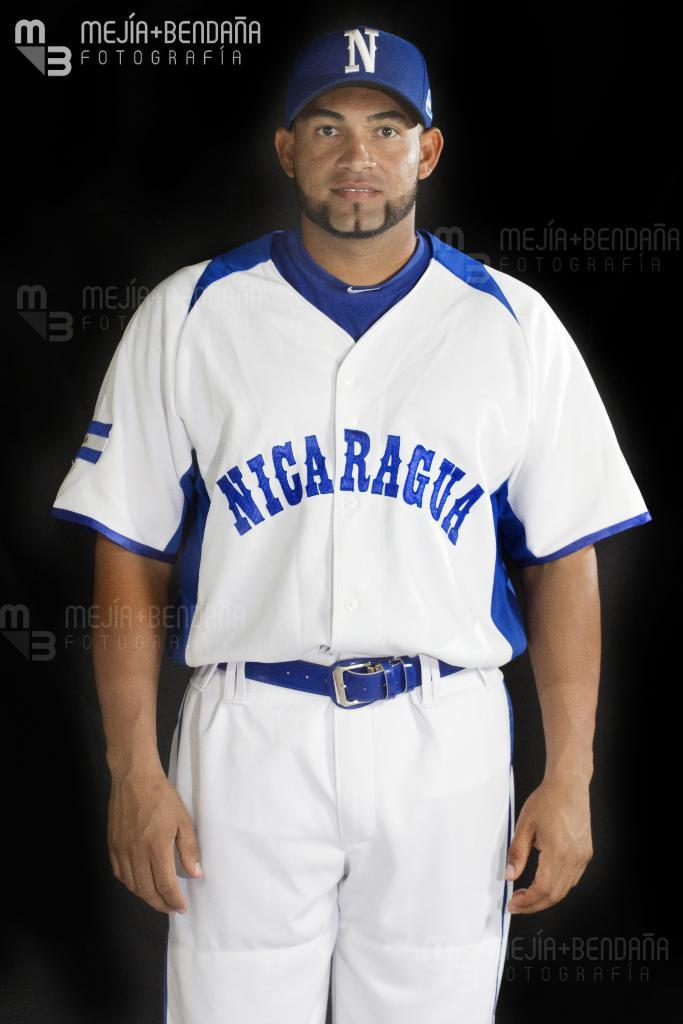<image>
Relay a brief, clear account of the picture shown. Baseball player wearing a white jersey which says "Nicaragua" on it. 